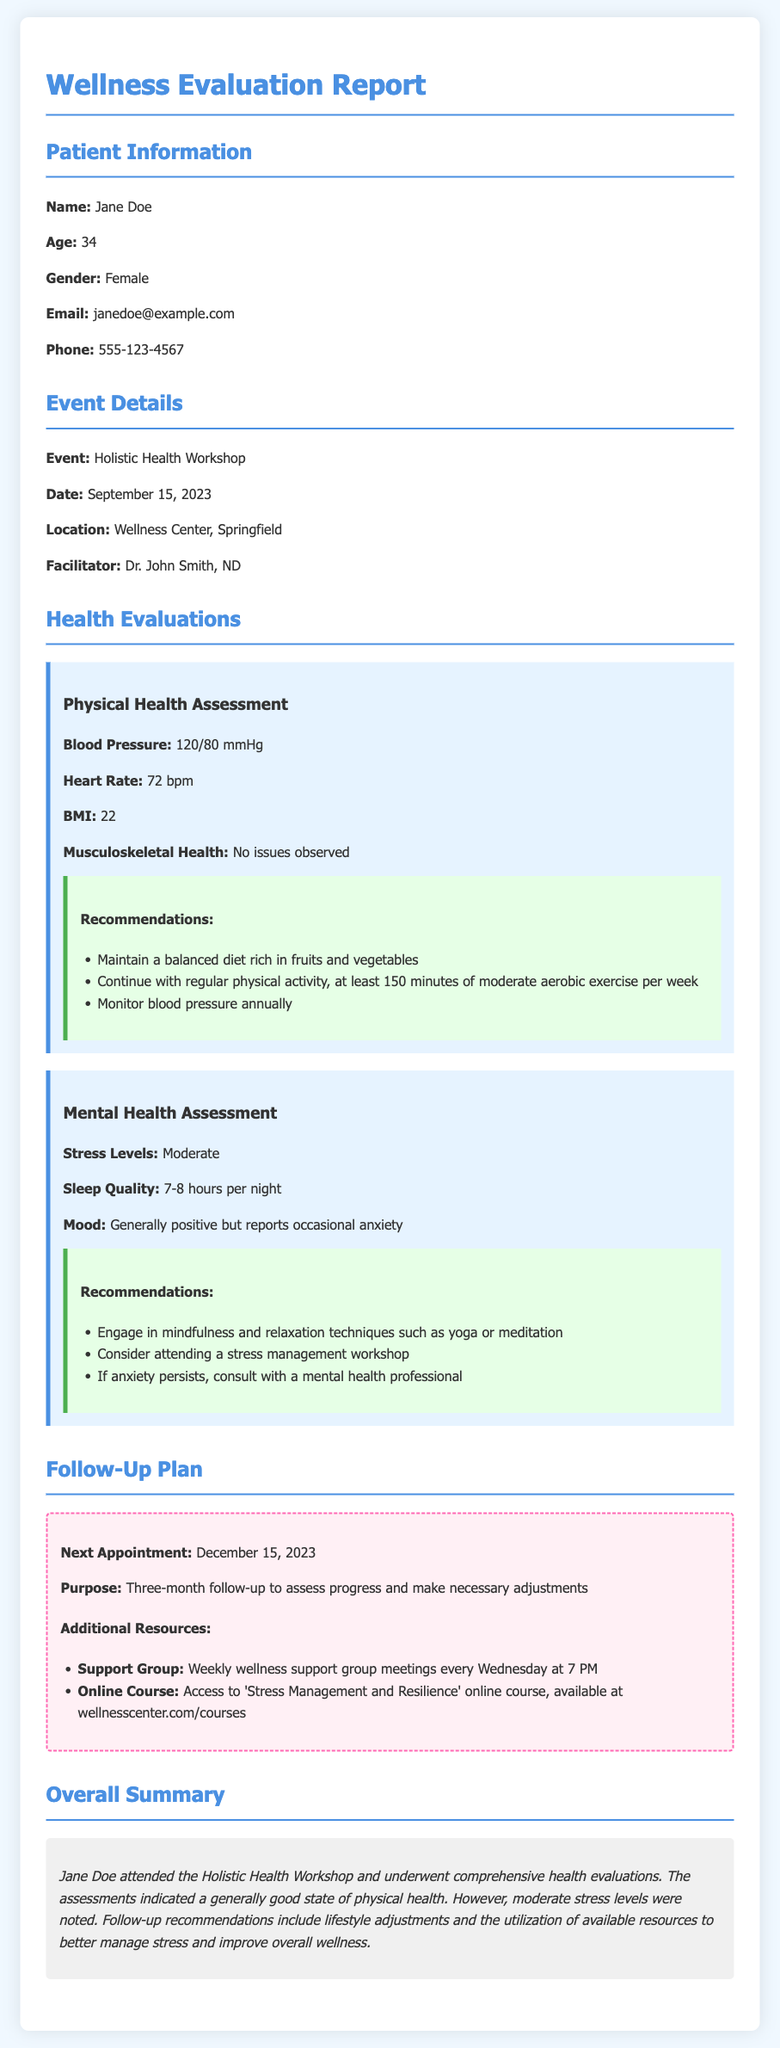what is the name of the patient? The name of the patient is listed in the Patient Information section of the document.
Answer: Jane Doe what was the event date? The date of the event is specified in the Event Details section.
Answer: September 15, 2023 who was the facilitator of the workshop? The facilitator's name is mentioned in the Event Details section of the document.
Answer: Dr. John Smith, ND what is Jane's blood pressure reading? The blood pressure reading is found in the Physical Health Assessment of the document.
Answer: 120/80 mmHg what recommendation was given for mental health? The recommendations for mental health are listed under the Mental Health Assessment.
Answer: Engage in mindfulness and relaxation techniques such as yoga or meditation how often should Jane monitor her blood pressure? This recommendation is provided under the Physical Health Assessment section.
Answer: Annually what is the purpose of the next appointment? The purpose of the appointment is detailed in the Follow-Up Plan section.
Answer: Three-month follow-up to assess progress and make necessary adjustments how many hours of sleep does Jane average per night? The average sleep quality is mentioned in the Mental Health Assessment.
Answer: 7-8 hours what type of group meetings are available for support? The type of group meetings is specified in the Additional Resources section.
Answer: Weekly wellness support group meetings what is the overall summary of Jane's evaluations? The overall summary provides a brief description of Jane's evaluation results and recommendations.
Answer: Good state of physical health with moderate stress levels noted 